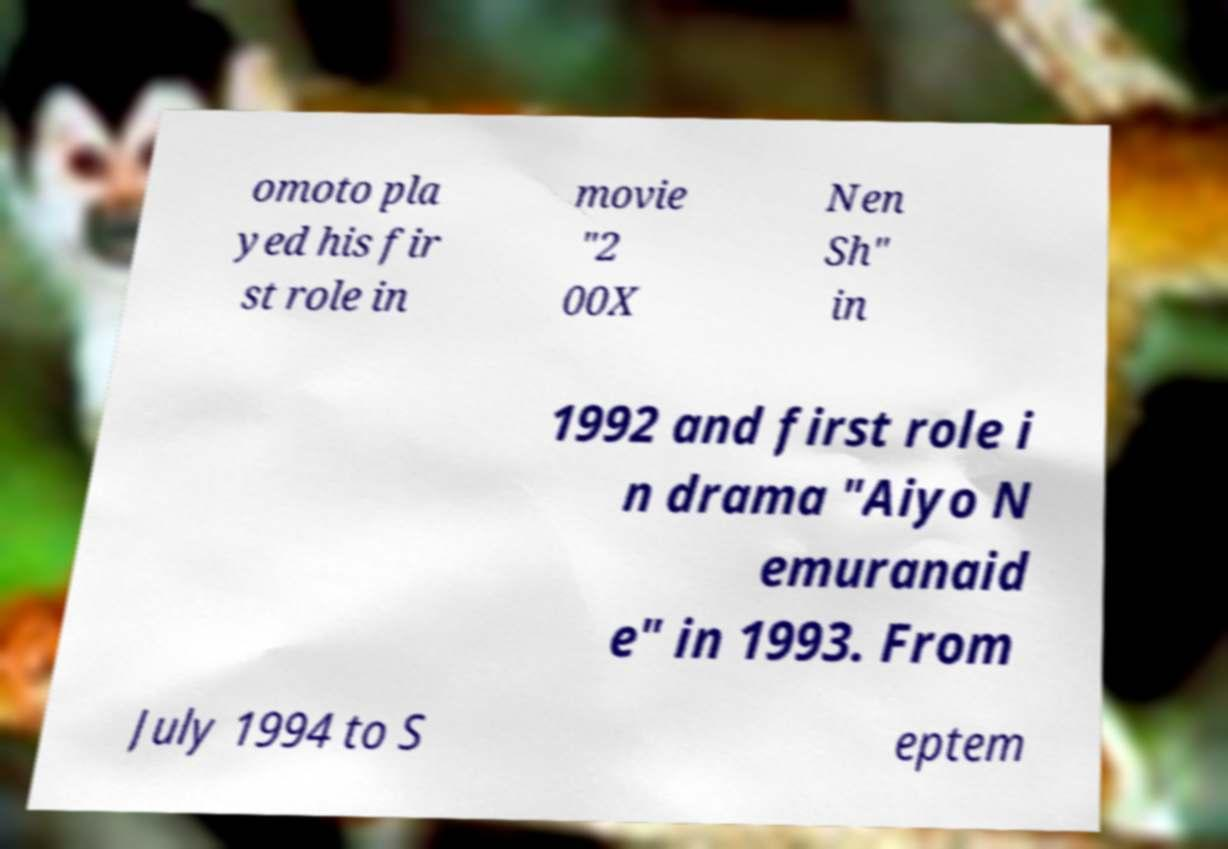Could you assist in decoding the text presented in this image and type it out clearly? omoto pla yed his fir st role in movie "2 00X Nen Sh" in 1992 and first role i n drama "Aiyo N emuranaid e" in 1993. From July 1994 to S eptem 